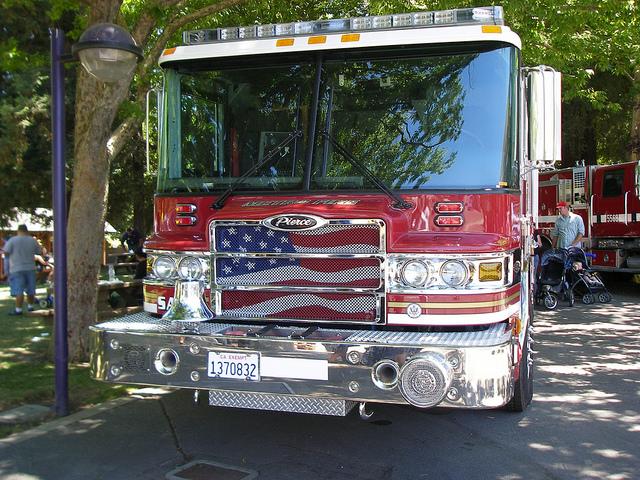What color is the vehicle?
Concise answer only. Red. Are there firemen?
Keep it brief. No. What is the nickname of the national flag on the front of the fire engine?
Short answer required. Old glory. 